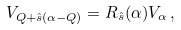<formula> <loc_0><loc_0><loc_500><loc_500>V _ { Q + \hat { s } ( \alpha - Q ) } = R _ { \hat { s } } ( \alpha ) V _ { \alpha } \, ,</formula> 